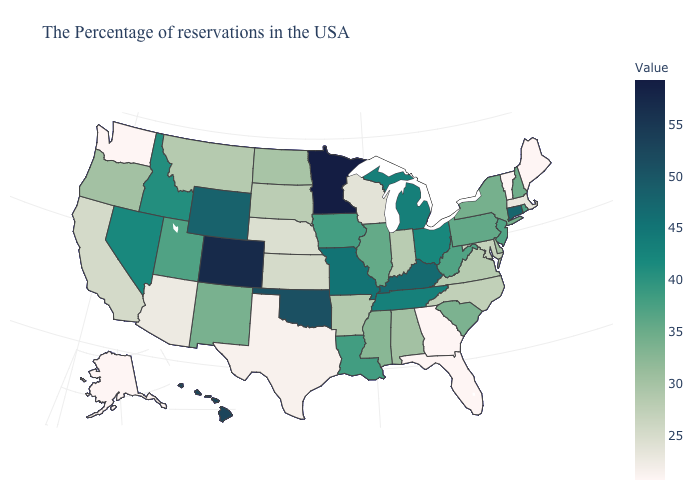Does Minnesota have the highest value in the USA?
Keep it brief. Yes. Does Minnesota have the highest value in the USA?
Short answer required. Yes. Does Massachusetts have the highest value in the Northeast?
Be succinct. No. Among the states that border California , does Arizona have the highest value?
Quick response, please. No. Does the map have missing data?
Be succinct. No. Which states hav the highest value in the MidWest?
Quick response, please. Minnesota. Does California have a higher value than Florida?
Keep it brief. Yes. Which states have the lowest value in the MidWest?
Quick response, please. Wisconsin. 